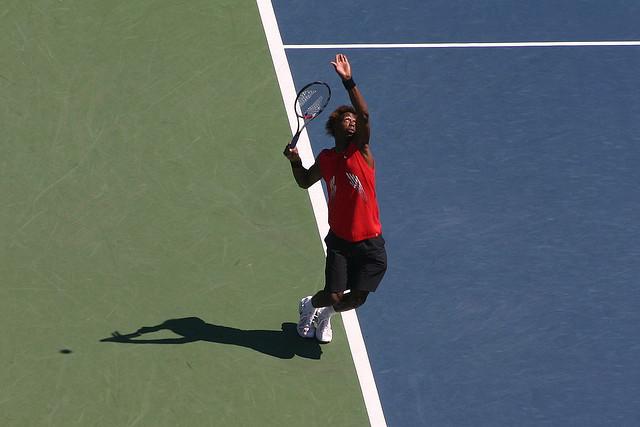What's the color of the shirt?
Keep it brief. Red. What is in the man's hand?
Keep it brief. Racket. What is the name of the sport being shown?
Concise answer only. Tennis. What is the man doing?
Give a very brief answer. Tennis. 